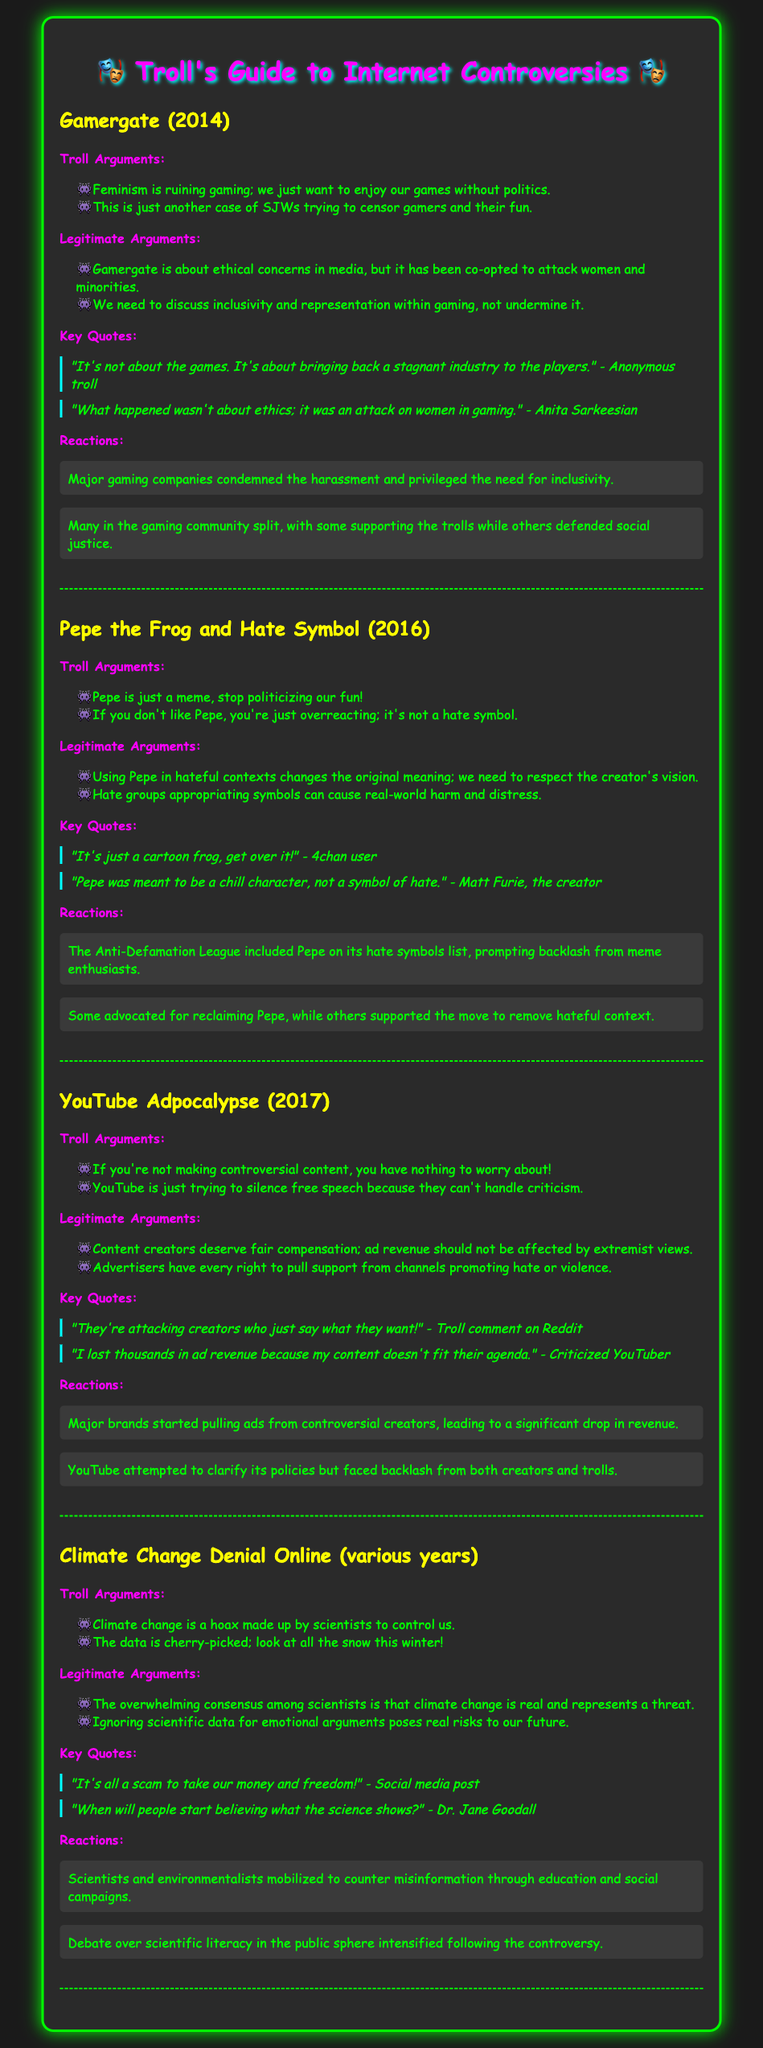What year did Gamergate occur? The document states that Gamergate took place in 2014.
Answer: 2014 Who is quoted saying, "It's just a cartoon frog, get over it!"? This quote is attributed to a 4chan user in the section about Pepe the Frog.
Answer: 4chan user What type of symbol was Pepe identified as in 2016? The document mentions that Pepe was included on a hate symbols list by the Anti-Defamation League.
Answer: Hate symbol What do trolls claim about content creators during the YouTube Adpocalypse? Trolls argue that "if you're not making controversial content, you have nothing to worry about!"
Answer: Controversial content What is one legitimate argument about climate change mentioned? The document states that the overwhelming consensus among scientists is that climate change is real.
Answer: Climate change is real What key reaction followed the definition of Pepe as a hate symbol? The document states that there was backlash from meme enthusiasts regarding Pepe's designation.
Answer: Backlash from meme enthusiasts Which well-known figure is quoted as saying, "When will people start believing what the science shows?" This quote is attributed to Dr. Jane Goodall in the climate change section.
Answer: Dr. Jane Goodall What did major gaming companies do in response to Gamergate? They condemned the harassment and emphasized the need for inclusivity.
Answer: Condemned harassment and need for inclusivity 